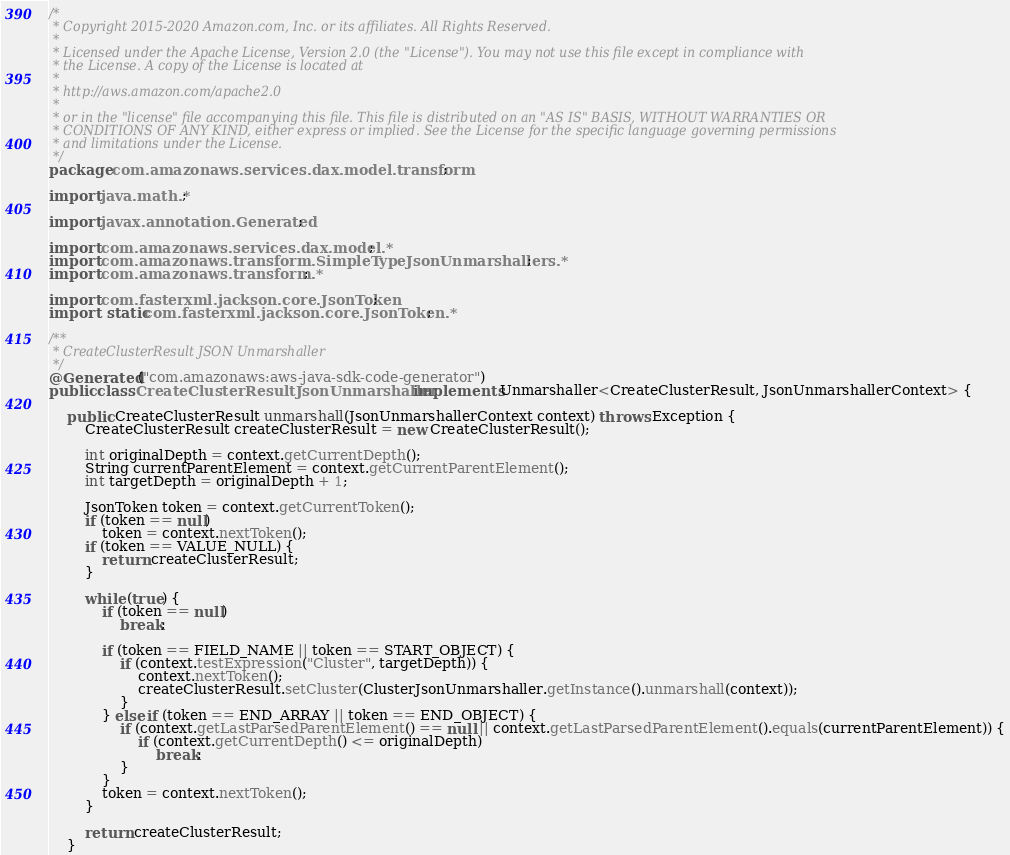Convert code to text. <code><loc_0><loc_0><loc_500><loc_500><_Java_>/*
 * Copyright 2015-2020 Amazon.com, Inc. or its affiliates. All Rights Reserved.
 * 
 * Licensed under the Apache License, Version 2.0 (the "License"). You may not use this file except in compliance with
 * the License. A copy of the License is located at
 * 
 * http://aws.amazon.com/apache2.0
 * 
 * or in the "license" file accompanying this file. This file is distributed on an "AS IS" BASIS, WITHOUT WARRANTIES OR
 * CONDITIONS OF ANY KIND, either express or implied. See the License for the specific language governing permissions
 * and limitations under the License.
 */
package com.amazonaws.services.dax.model.transform;

import java.math.*;

import javax.annotation.Generated;

import com.amazonaws.services.dax.model.*;
import com.amazonaws.transform.SimpleTypeJsonUnmarshallers.*;
import com.amazonaws.transform.*;

import com.fasterxml.jackson.core.JsonToken;
import static com.fasterxml.jackson.core.JsonToken.*;

/**
 * CreateClusterResult JSON Unmarshaller
 */
@Generated("com.amazonaws:aws-java-sdk-code-generator")
public class CreateClusterResultJsonUnmarshaller implements Unmarshaller<CreateClusterResult, JsonUnmarshallerContext> {

    public CreateClusterResult unmarshall(JsonUnmarshallerContext context) throws Exception {
        CreateClusterResult createClusterResult = new CreateClusterResult();

        int originalDepth = context.getCurrentDepth();
        String currentParentElement = context.getCurrentParentElement();
        int targetDepth = originalDepth + 1;

        JsonToken token = context.getCurrentToken();
        if (token == null)
            token = context.nextToken();
        if (token == VALUE_NULL) {
            return createClusterResult;
        }

        while (true) {
            if (token == null)
                break;

            if (token == FIELD_NAME || token == START_OBJECT) {
                if (context.testExpression("Cluster", targetDepth)) {
                    context.nextToken();
                    createClusterResult.setCluster(ClusterJsonUnmarshaller.getInstance().unmarshall(context));
                }
            } else if (token == END_ARRAY || token == END_OBJECT) {
                if (context.getLastParsedParentElement() == null || context.getLastParsedParentElement().equals(currentParentElement)) {
                    if (context.getCurrentDepth() <= originalDepth)
                        break;
                }
            }
            token = context.nextToken();
        }

        return createClusterResult;
    }
</code> 